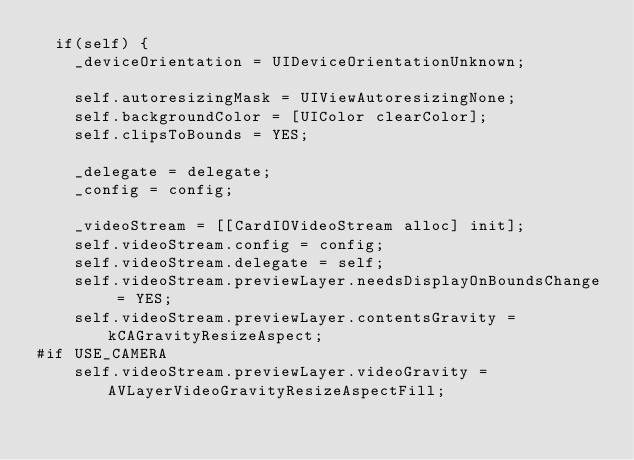Convert code to text. <code><loc_0><loc_0><loc_500><loc_500><_ObjectiveC_>  if(self) {
    _deviceOrientation = UIDeviceOrientationUnknown;
    
    self.autoresizingMask = UIViewAutoresizingNone;
    self.backgroundColor = [UIColor clearColor];
    self.clipsToBounds = YES;
    
    _delegate = delegate;
    _config = config;
    
    _videoStream = [[CardIOVideoStream alloc] init];
    self.videoStream.config = config;
    self.videoStream.delegate = self;
    self.videoStream.previewLayer.needsDisplayOnBoundsChange = YES;
    self.videoStream.previewLayer.contentsGravity = kCAGravityResizeAspect;
#if USE_CAMERA
    self.videoStream.previewLayer.videoGravity = AVLayerVideoGravityResizeAspectFill;</code> 